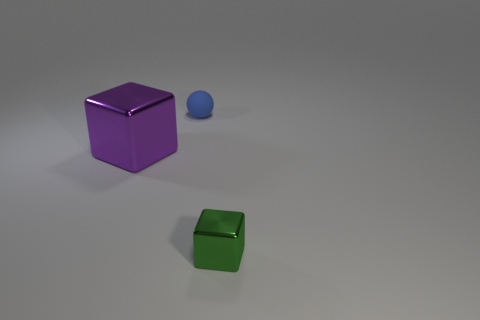Add 2 large cubes. How many objects exist? 5 Subtract all spheres. How many objects are left? 2 Subtract all small rubber balls. Subtract all large purple metallic cylinders. How many objects are left? 2 Add 2 tiny green metal blocks. How many tiny green metal blocks are left? 3 Add 2 tiny yellow metallic objects. How many tiny yellow metallic objects exist? 2 Subtract 0 cyan balls. How many objects are left? 3 Subtract all green blocks. Subtract all yellow spheres. How many blocks are left? 1 